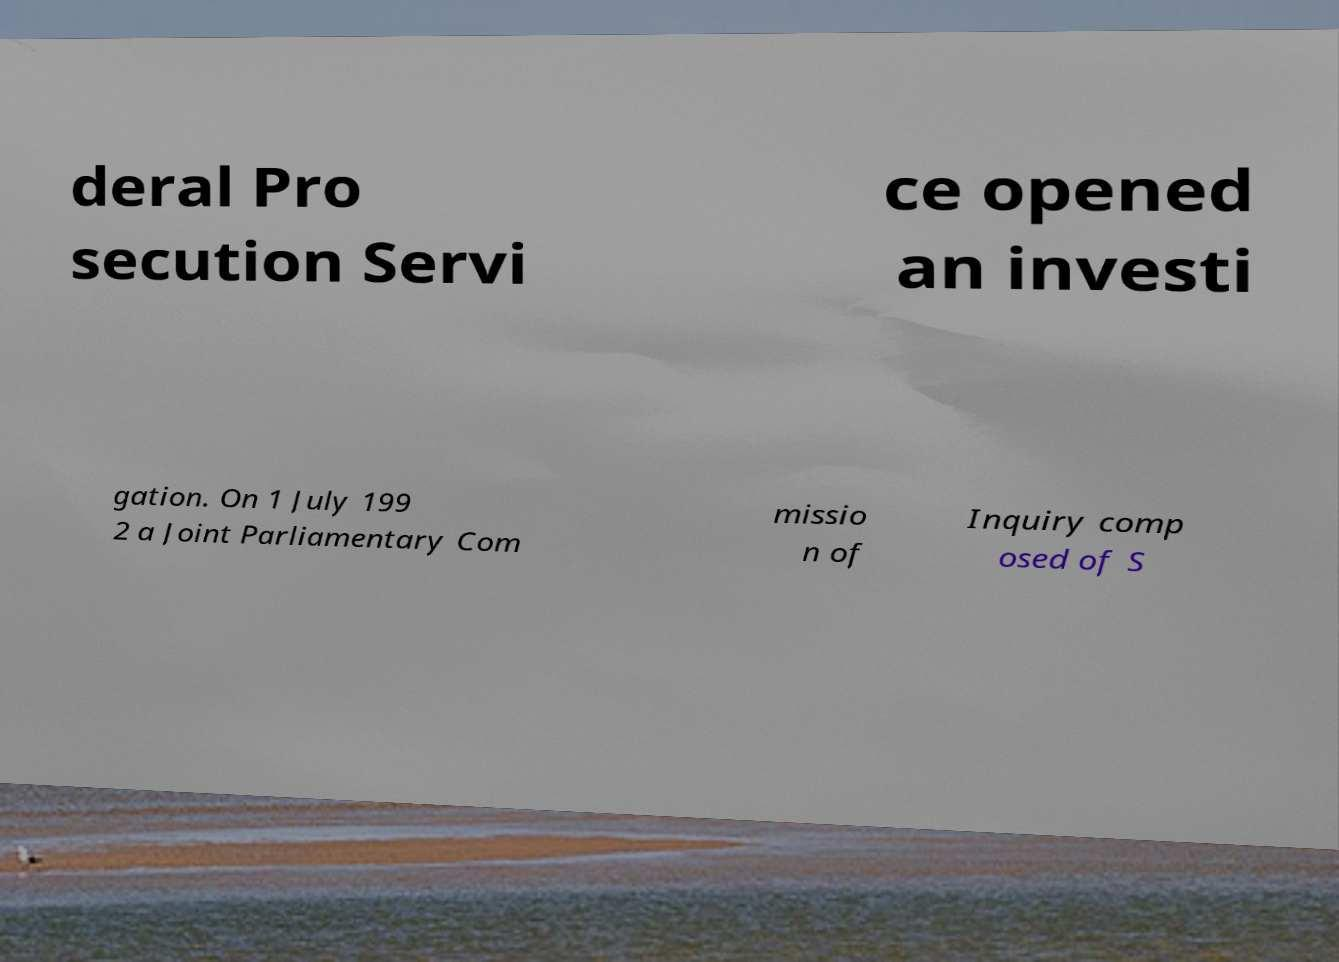Can you accurately transcribe the text from the provided image for me? deral Pro secution Servi ce opened an investi gation. On 1 July 199 2 a Joint Parliamentary Com missio n of Inquiry comp osed of S 